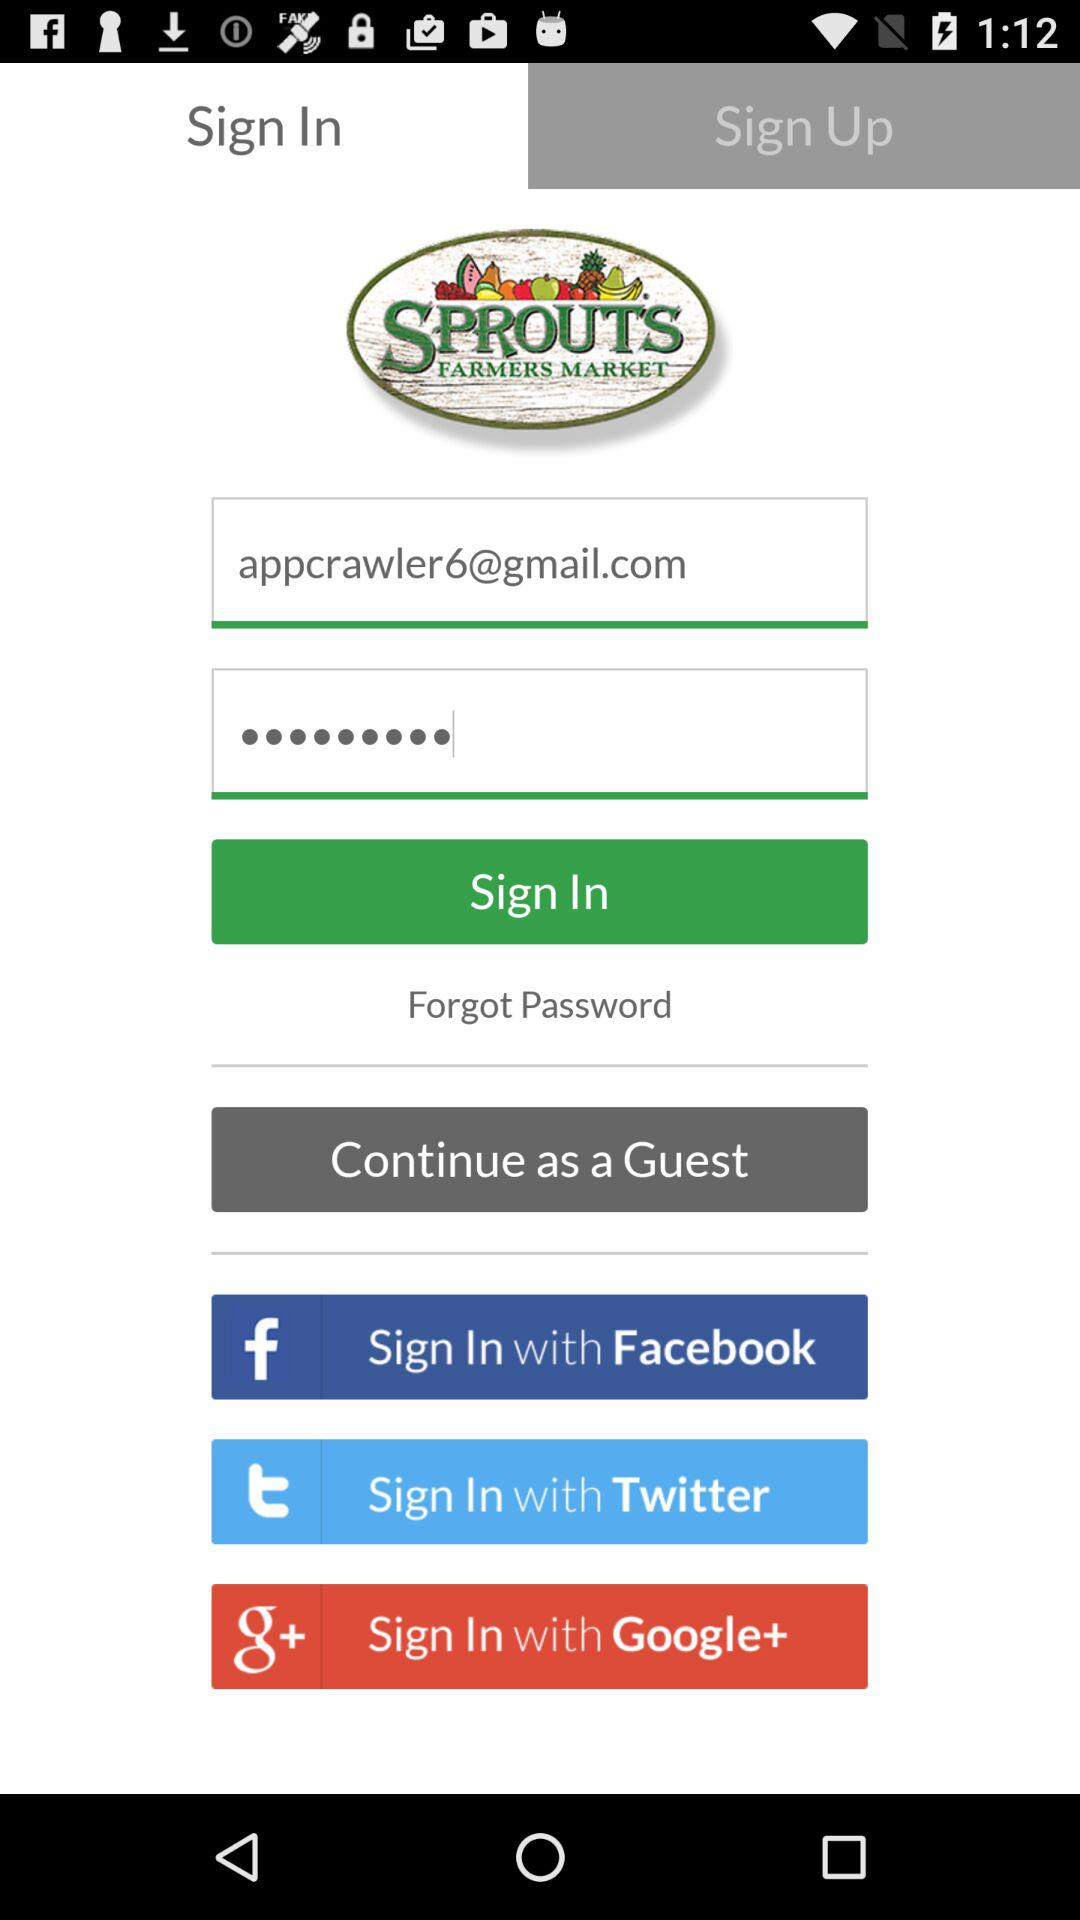What is the email address? The email address is appcrawler6@gmail.com. 